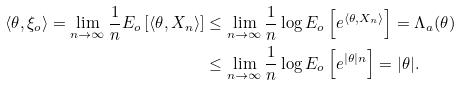<formula> <loc_0><loc_0><loc_500><loc_500>\langle \theta , \xi _ { o } \rangle = \lim _ { n \to \infty } \frac { 1 } { n } E _ { o } \left [ \langle \theta , X _ { n } \rangle \right ] & \leq \lim _ { n \to \infty } \frac { 1 } { n } \log E _ { o } \left [ e ^ { \langle \theta , X _ { n } \rangle } \right ] = \Lambda _ { a } ( \theta ) \\ & \leq \lim _ { n \to \infty } \frac { 1 } { n } \log E _ { o } \left [ e ^ { | \theta | n } \right ] = | \theta | .</formula> 